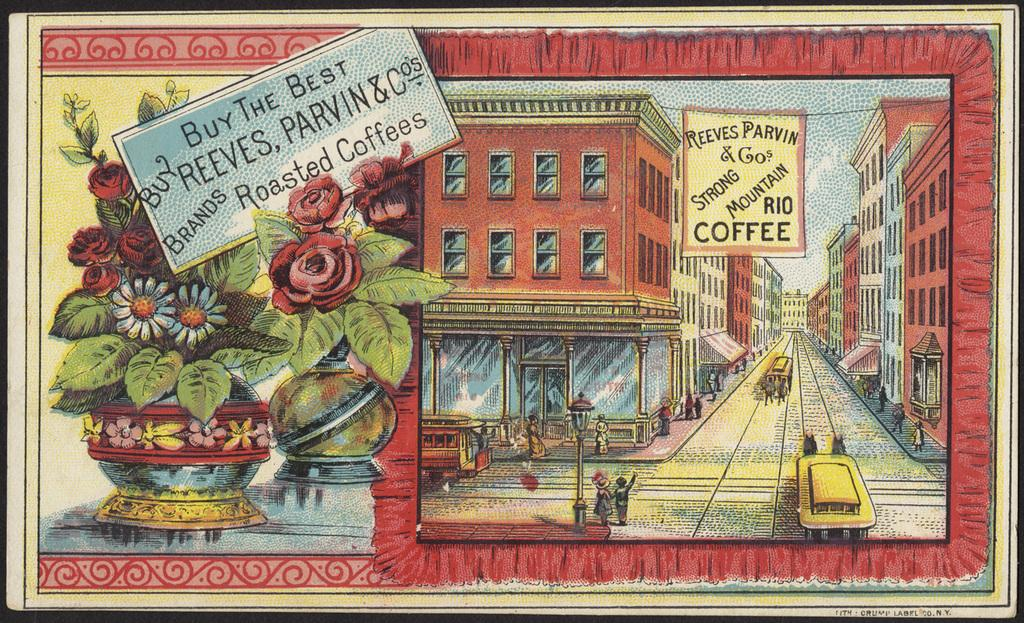<image>
Write a terse but informative summary of the picture. An advertisement says "buy the best roasted coffees" and features the brand Reeves, Parvin & Co. 